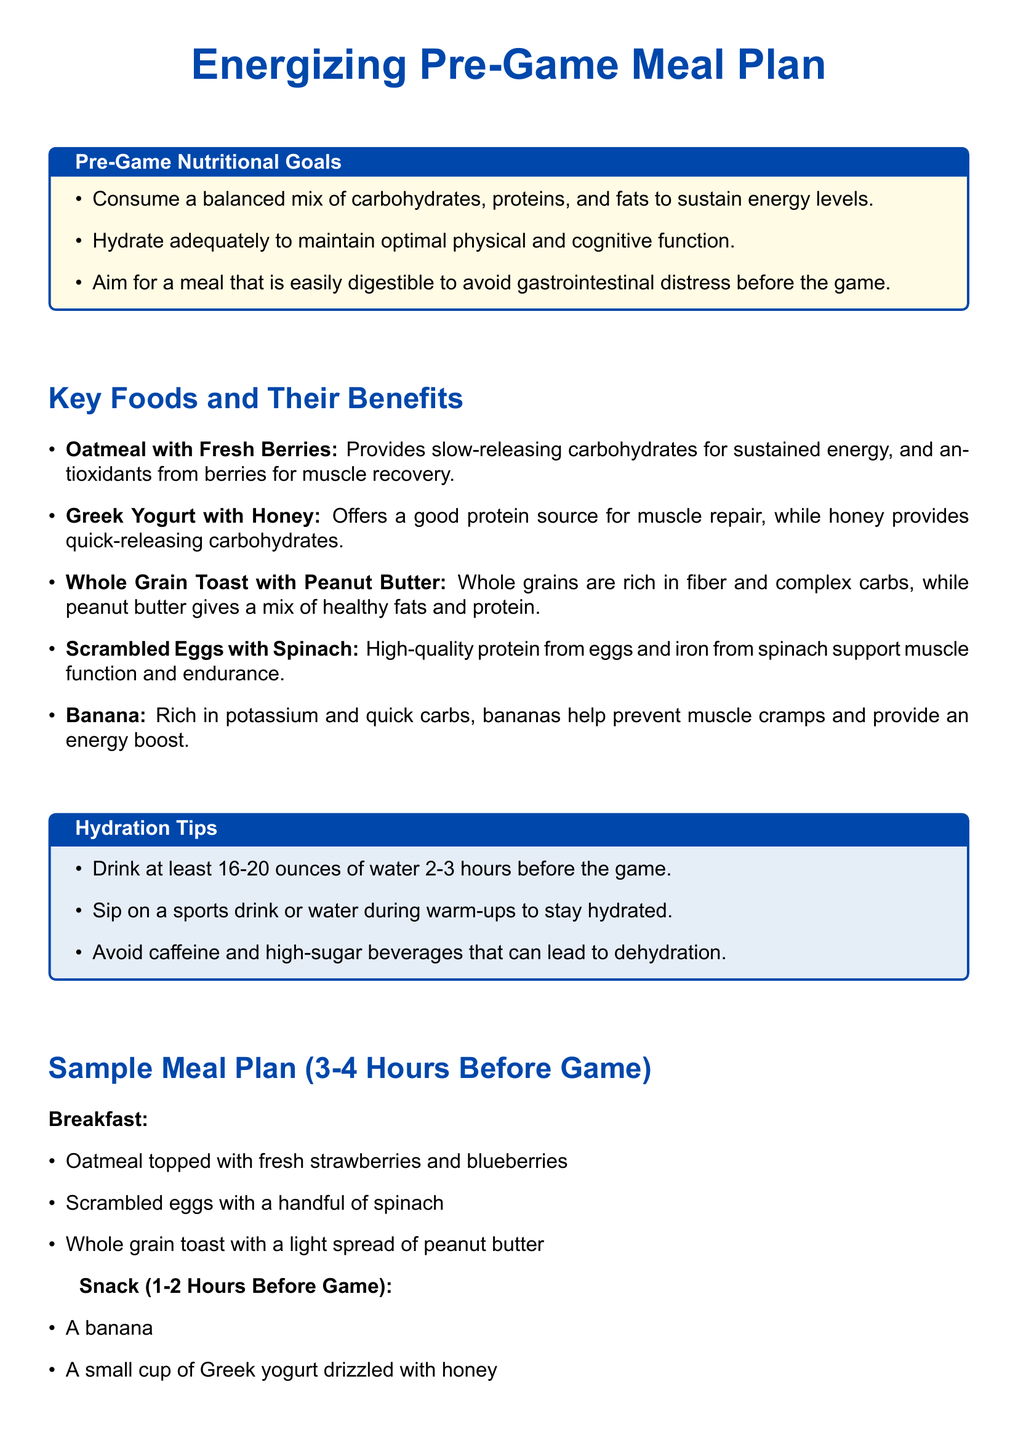What is the main focus of the pre-game meal plan? The main focus is to provide foods that boost performance on the field.
Answer: Boost performance What should you drink 2-3 hours before the game? The document suggests drinking at least 16-20 ounces of water.
Answer: Water What is one benefit of oatmeal with fresh berries? Oatmeal provides slow-releasing carbohydrates for sustained energy.
Answer: Sustained energy How many ounces of water is recommended to drink during the pre-game period? The plan recommends 20 ounces of water.
Answer: 20 ounces What food item is recommended for muscle cramps? A banana is rich in potassium and helps prevent muscle cramps.
Answer: Banana What type of protein is included in the scrambled eggs dish? The scrambled eggs dish provides high-quality protein.
Answer: High-quality protein What should be avoided according to the hydration tips? Caffeine and high-sugar beverages are advised to be avoided.
Answer: Caffeine and high-sugar beverages What is suggested to eat 1-2 hours before the game? A small cup of Greek yogurt drizzled with honey is suggested.
Answer: Greek yogurt with honey What does the meal plan encourage for energy maintenance? The meal plan encourages a balanced mix of carbohydrates, proteins, and fats.
Answer: Balanced mix of nutrients 